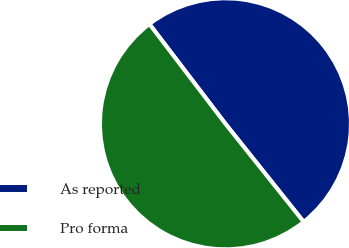<chart> <loc_0><loc_0><loc_500><loc_500><pie_chart><fcel>As reported<fcel>Pro forma<nl><fcel>49.65%<fcel>50.35%<nl></chart> 